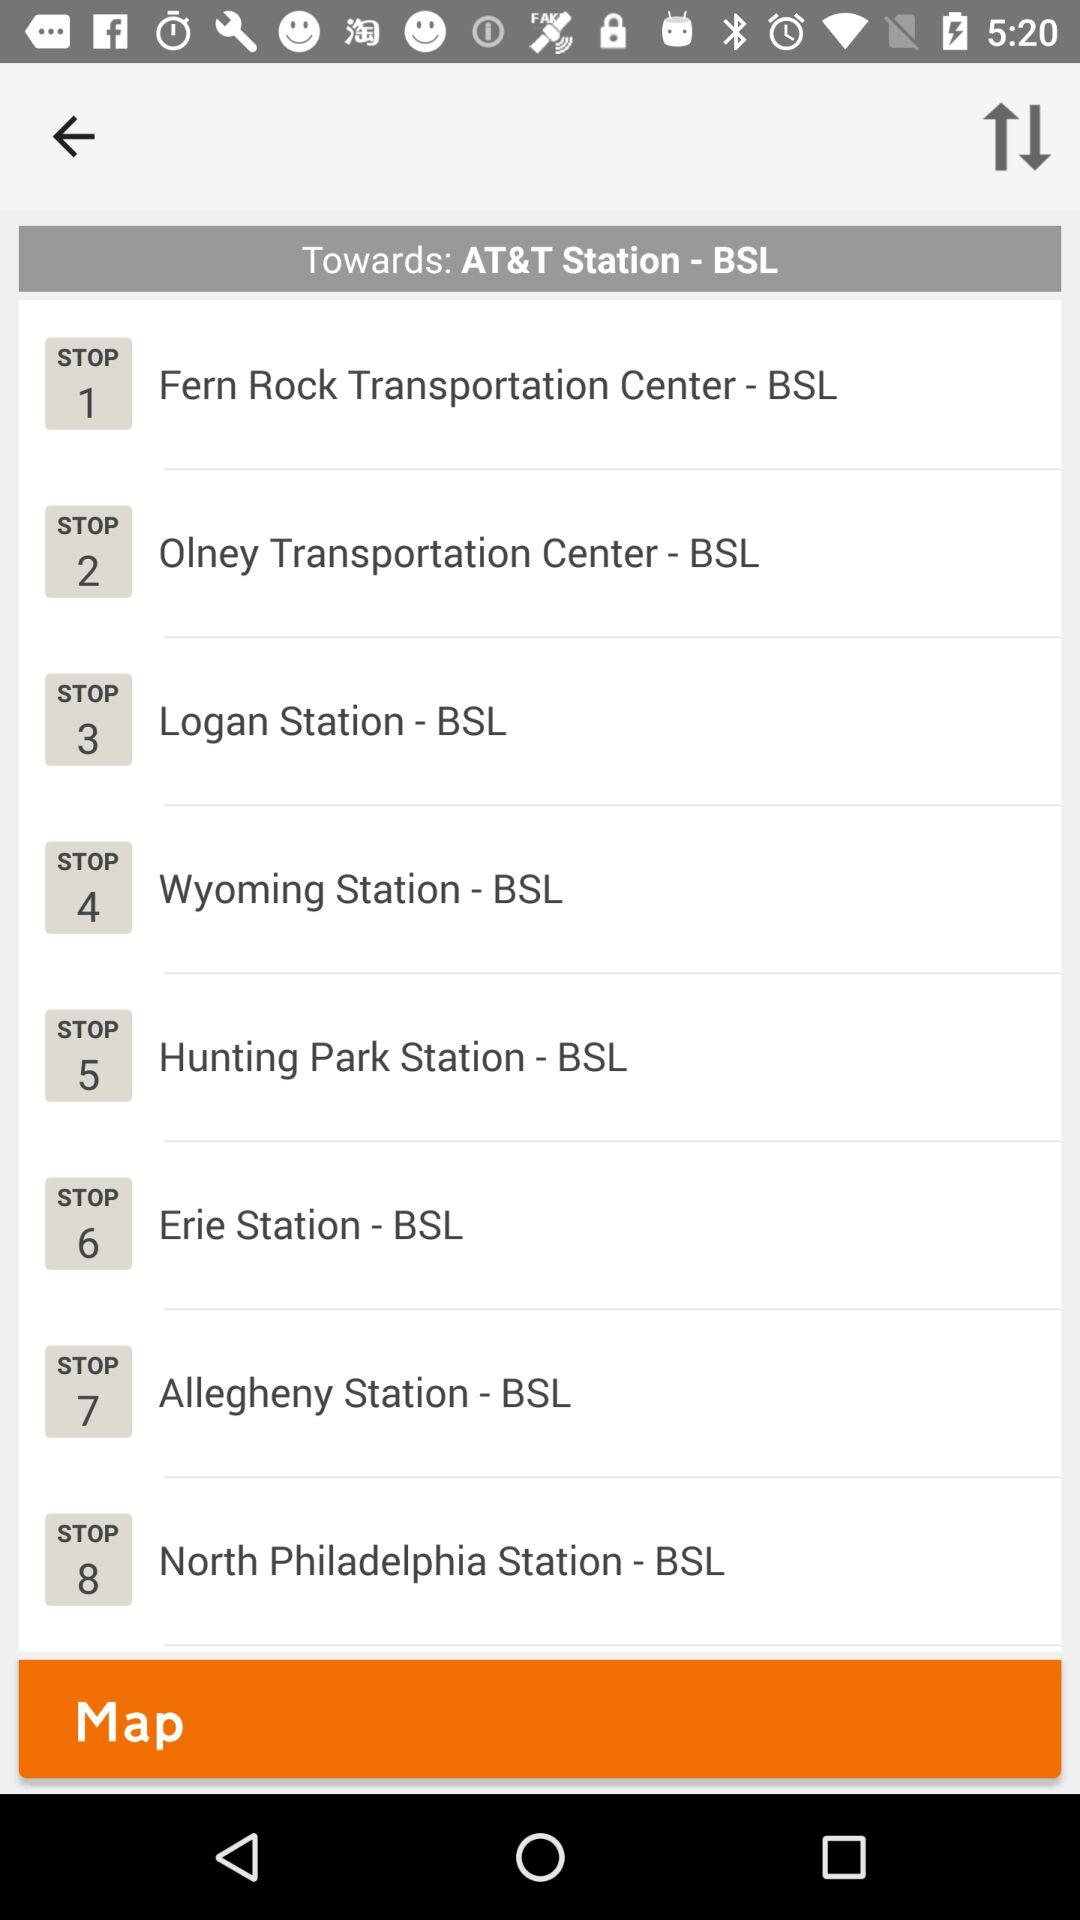What is the station name for Stop 8? The station name for Stop 8 is "North Philadelphia Station - BSL". 